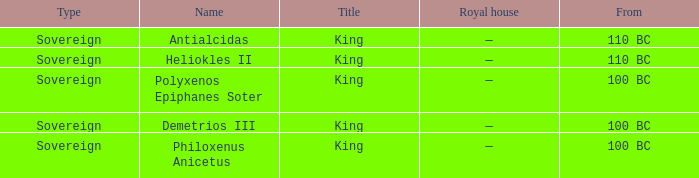When did philoxenus anicetus initiate his rule? 100 BC. 